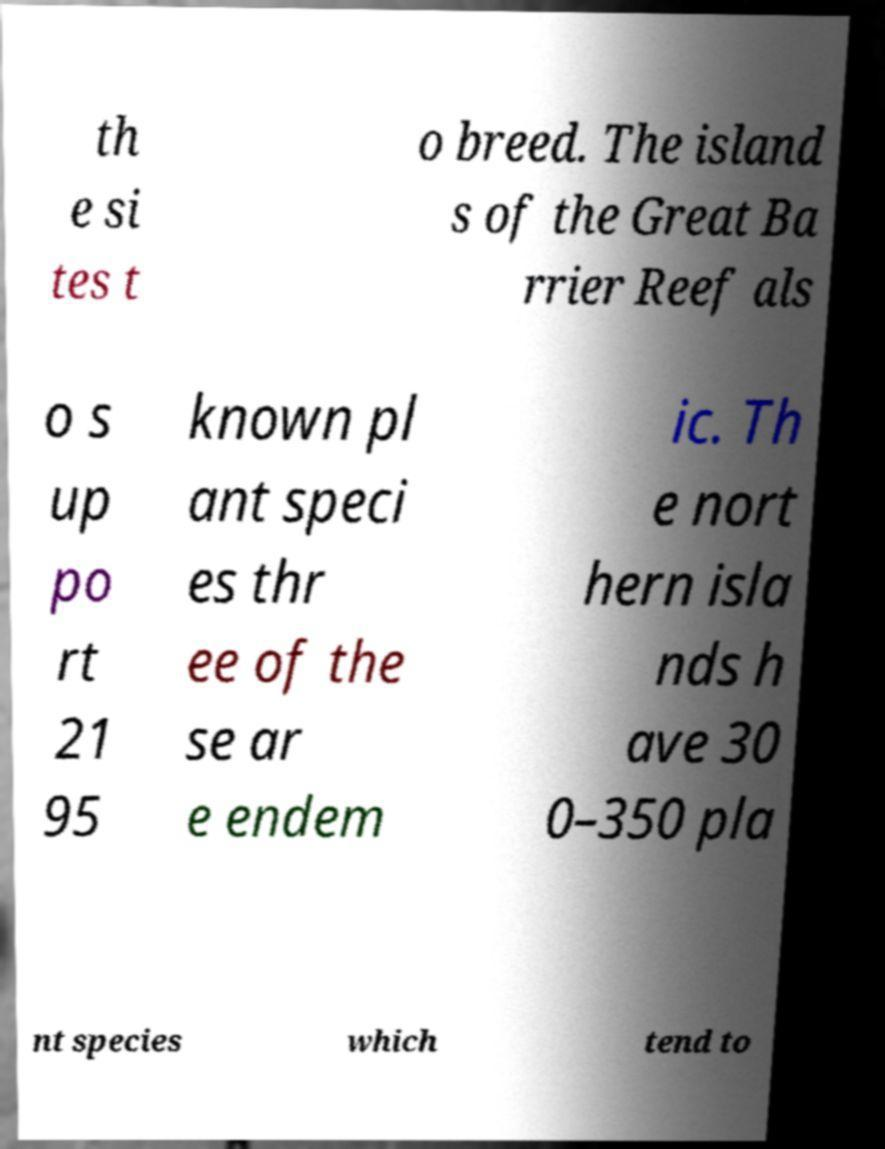Please read and relay the text visible in this image. What does it say? th e si tes t o breed. The island s of the Great Ba rrier Reef als o s up po rt 21 95 known pl ant speci es thr ee of the se ar e endem ic. Th e nort hern isla nds h ave 30 0–350 pla nt species which tend to 